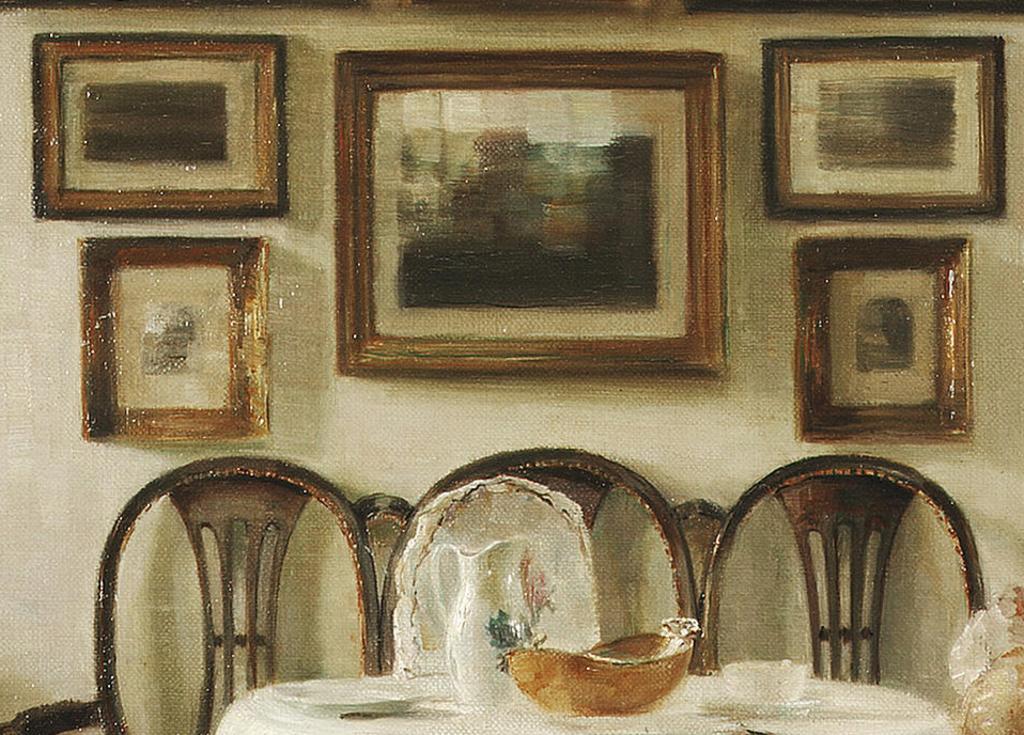Can you describe this image briefly? In this picture I can see some chairs, table on which there are some bowls, mug are placed, behind I can see some frames to the wall. 